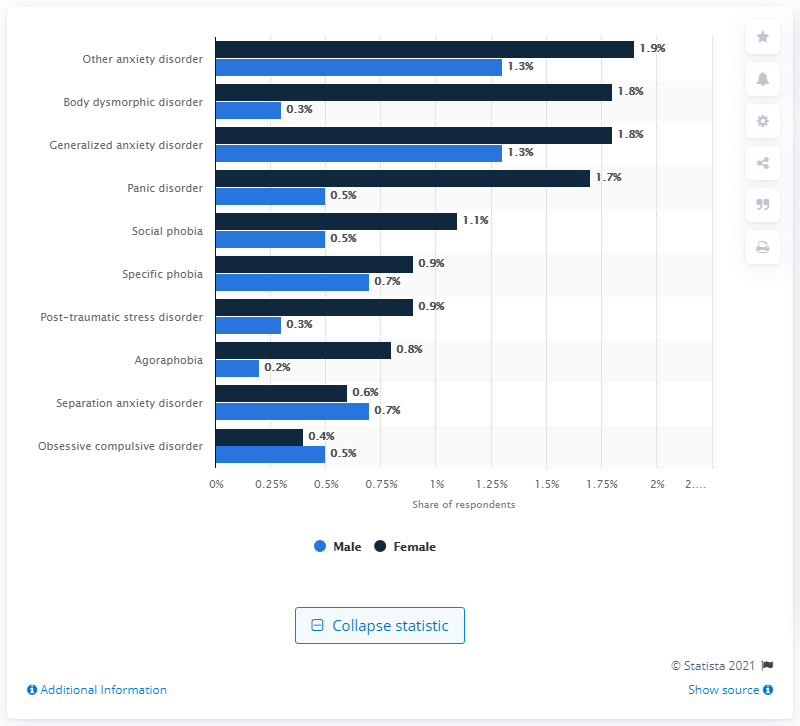Highlight a few significant elements in this photo. In the given text, it is stated that the total percentage of individuals with panic disorder and social phobia is 3.8%. This information pertains to both males and females. The percentage of females with panic disorder is 1.7%. 